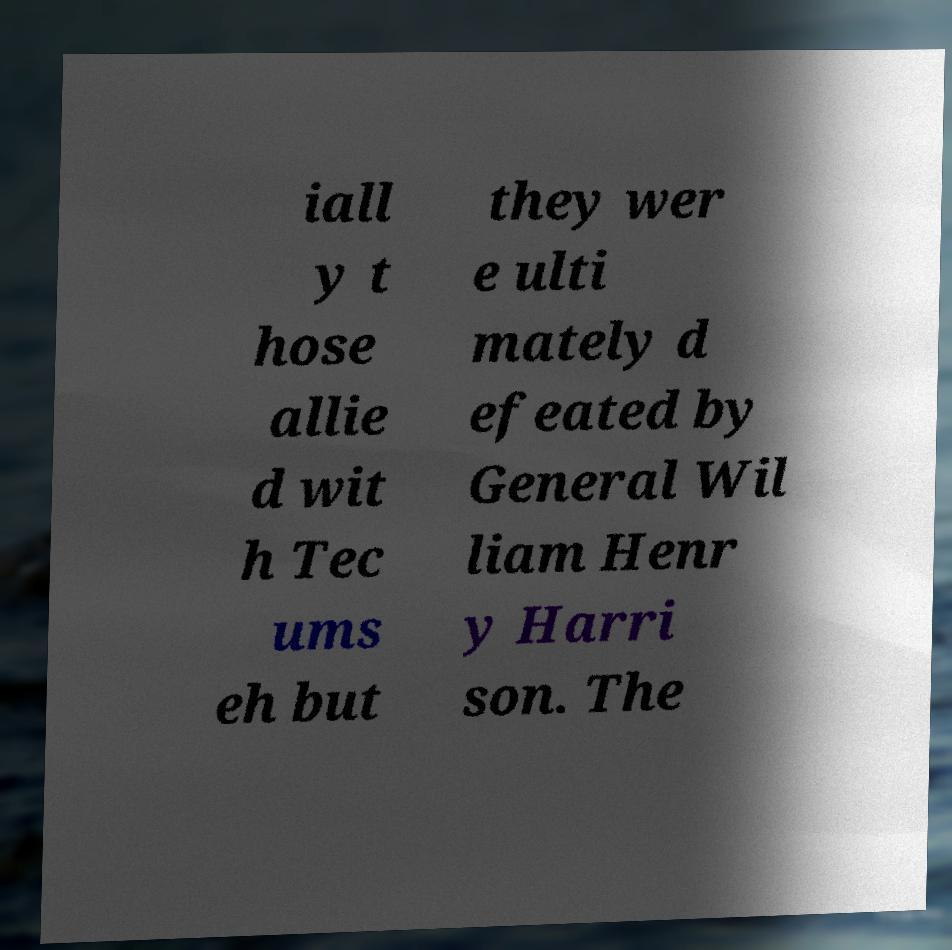I need the written content from this picture converted into text. Can you do that? iall y t hose allie d wit h Tec ums eh but they wer e ulti mately d efeated by General Wil liam Henr y Harri son. The 